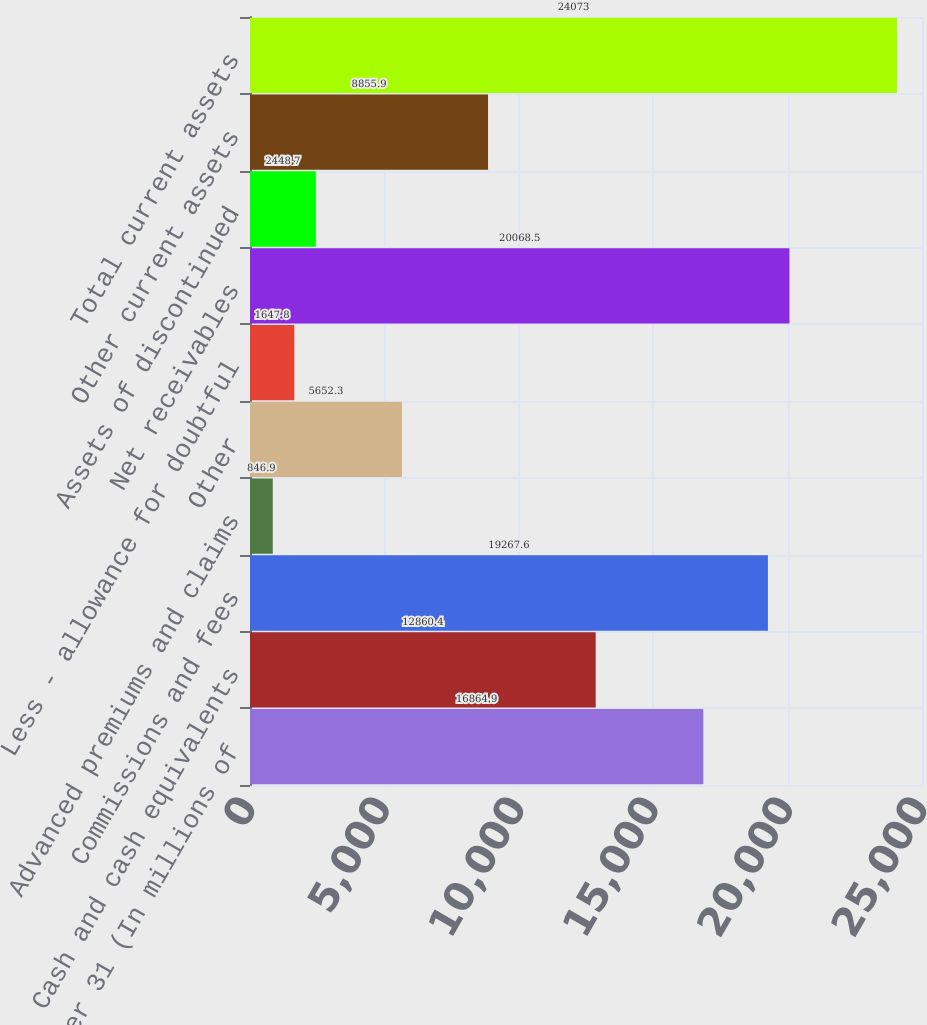Convert chart to OTSL. <chart><loc_0><loc_0><loc_500><loc_500><bar_chart><fcel>December 31 (In millions of<fcel>Cash and cash equivalents<fcel>Commissions and fees<fcel>Advanced premiums and claims<fcel>Other<fcel>Less - allowance for doubtful<fcel>Net receivables<fcel>Assets of discontinued<fcel>Other current assets<fcel>Total current assets<nl><fcel>16864.9<fcel>12860.4<fcel>19267.6<fcel>846.9<fcel>5652.3<fcel>1647.8<fcel>20068.5<fcel>2448.7<fcel>8855.9<fcel>24073<nl></chart> 